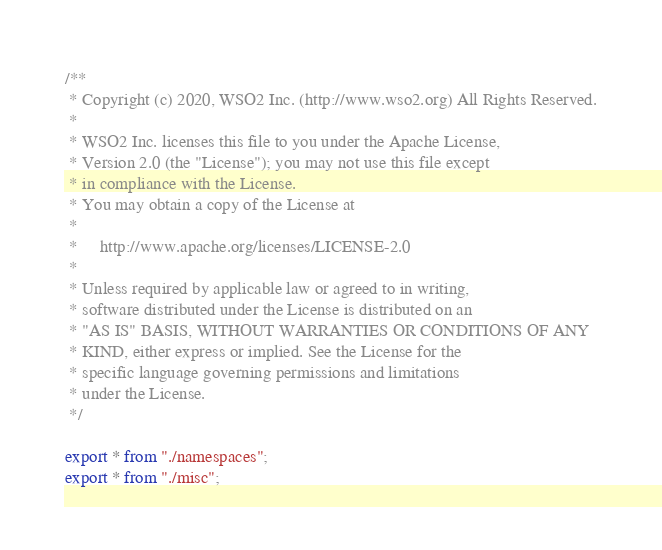<code> <loc_0><loc_0><loc_500><loc_500><_TypeScript_>/**
 * Copyright (c) 2020, WSO2 Inc. (http://www.wso2.org) All Rights Reserved.
 *
 * WSO2 Inc. licenses this file to you under the Apache License,
 * Version 2.0 (the "License"); you may not use this file except
 * in compliance with the License.
 * You may obtain a copy of the License at
 *
 *     http://www.apache.org/licenses/LICENSE-2.0
 *
 * Unless required by applicable law or agreed to in writing,
 * software distributed under the License is distributed on an
 * "AS IS" BASIS, WITHOUT WARRANTIES OR CONDITIONS OF ANY
 * KIND, either express or implied. See the License for the
 * specific language governing permissions and limitations
 * under the License.
 */

export * from "./namespaces";
export * from "./misc";
</code> 